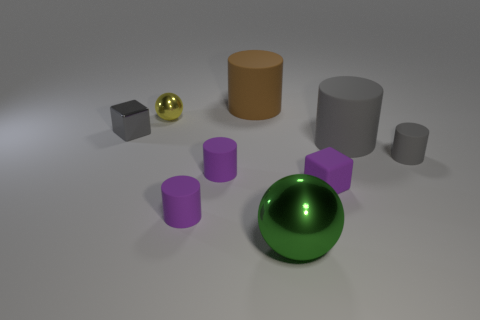Subtract all brown cylinders. How many cylinders are left? 4 Subtract all blue cylinders. Subtract all brown blocks. How many cylinders are left? 5 Subtract all blocks. How many objects are left? 7 Add 5 large brown things. How many large brown things exist? 6 Subtract 0 purple spheres. How many objects are left? 9 Subtract all small metal objects. Subtract all gray metallic things. How many objects are left? 6 Add 7 small purple matte cubes. How many small purple matte cubes are left? 8 